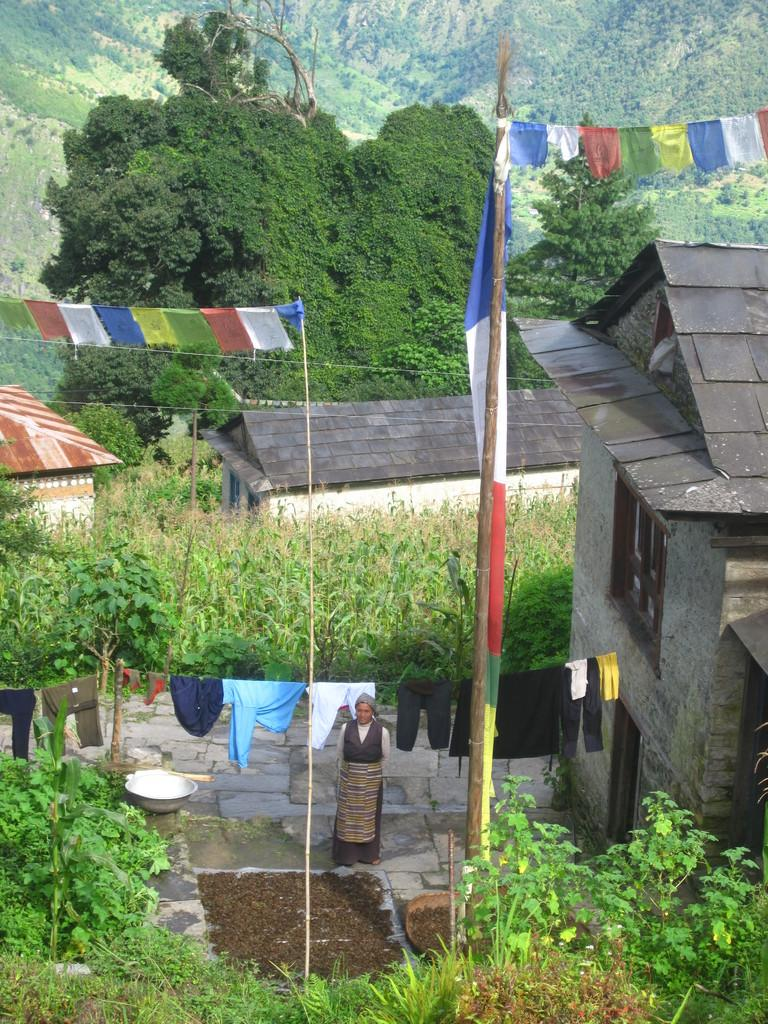What is the main subject of the image? There is a person standing in the center of the image. What objects can be seen in the image besides the person? Poles, clothes, garlands, plants, baskets, and buildings are present in the image. What can be seen in the background of the image? Hills and trees are visible in the background of the image. How many bananas are hanging from the poles in the image? There are no bananas present in the image; only poles, clothes, garlands, plants, baskets, and buildings can be seen. What type of yard is visible in the image? There is no yard visible in the image; the background features hills and trees. 